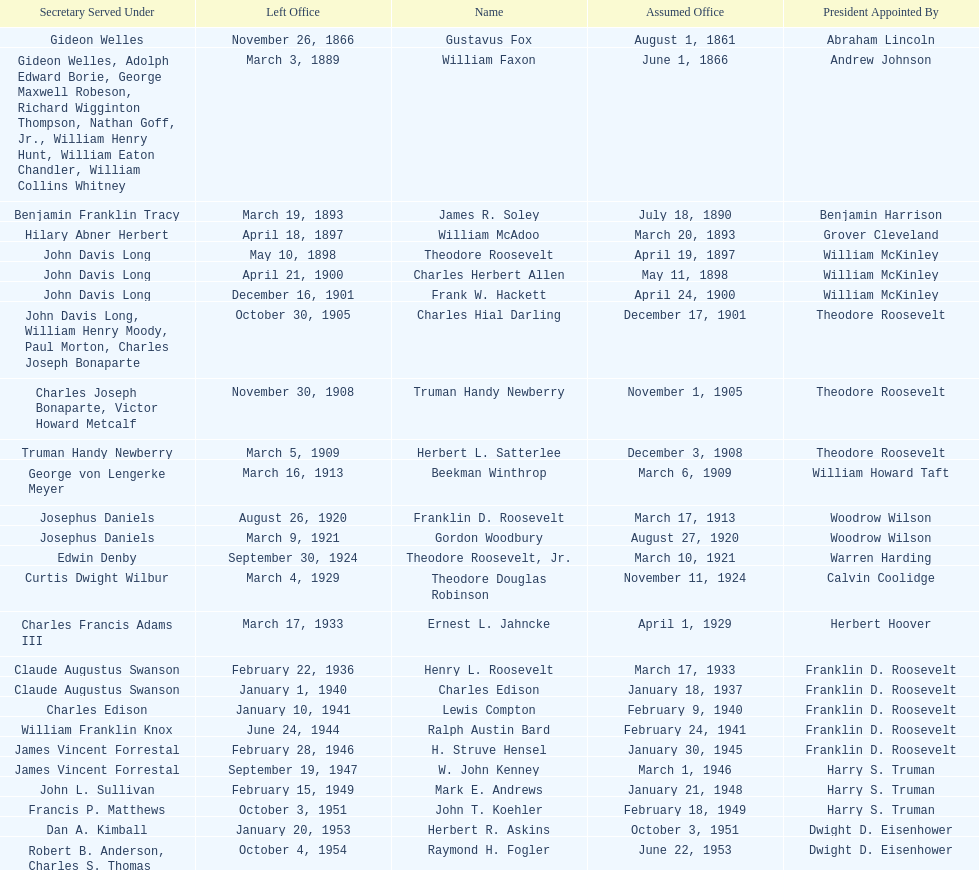Who was the first assistant secretary of the navy? Gustavus Fox. 